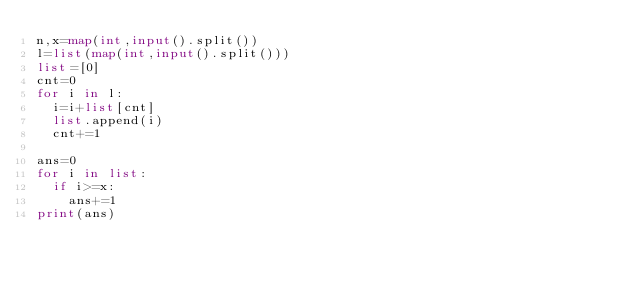<code> <loc_0><loc_0><loc_500><loc_500><_Python_>n,x=map(int,input().split())
l=list(map(int,input().split()))
list=[0]
cnt=0
for i in l:
  i=i+list[cnt]
  list.append(i)
  cnt+=1

ans=0
for i in list:
  if i>=x:
    ans+=1
print(ans)
  
  
  </code> 